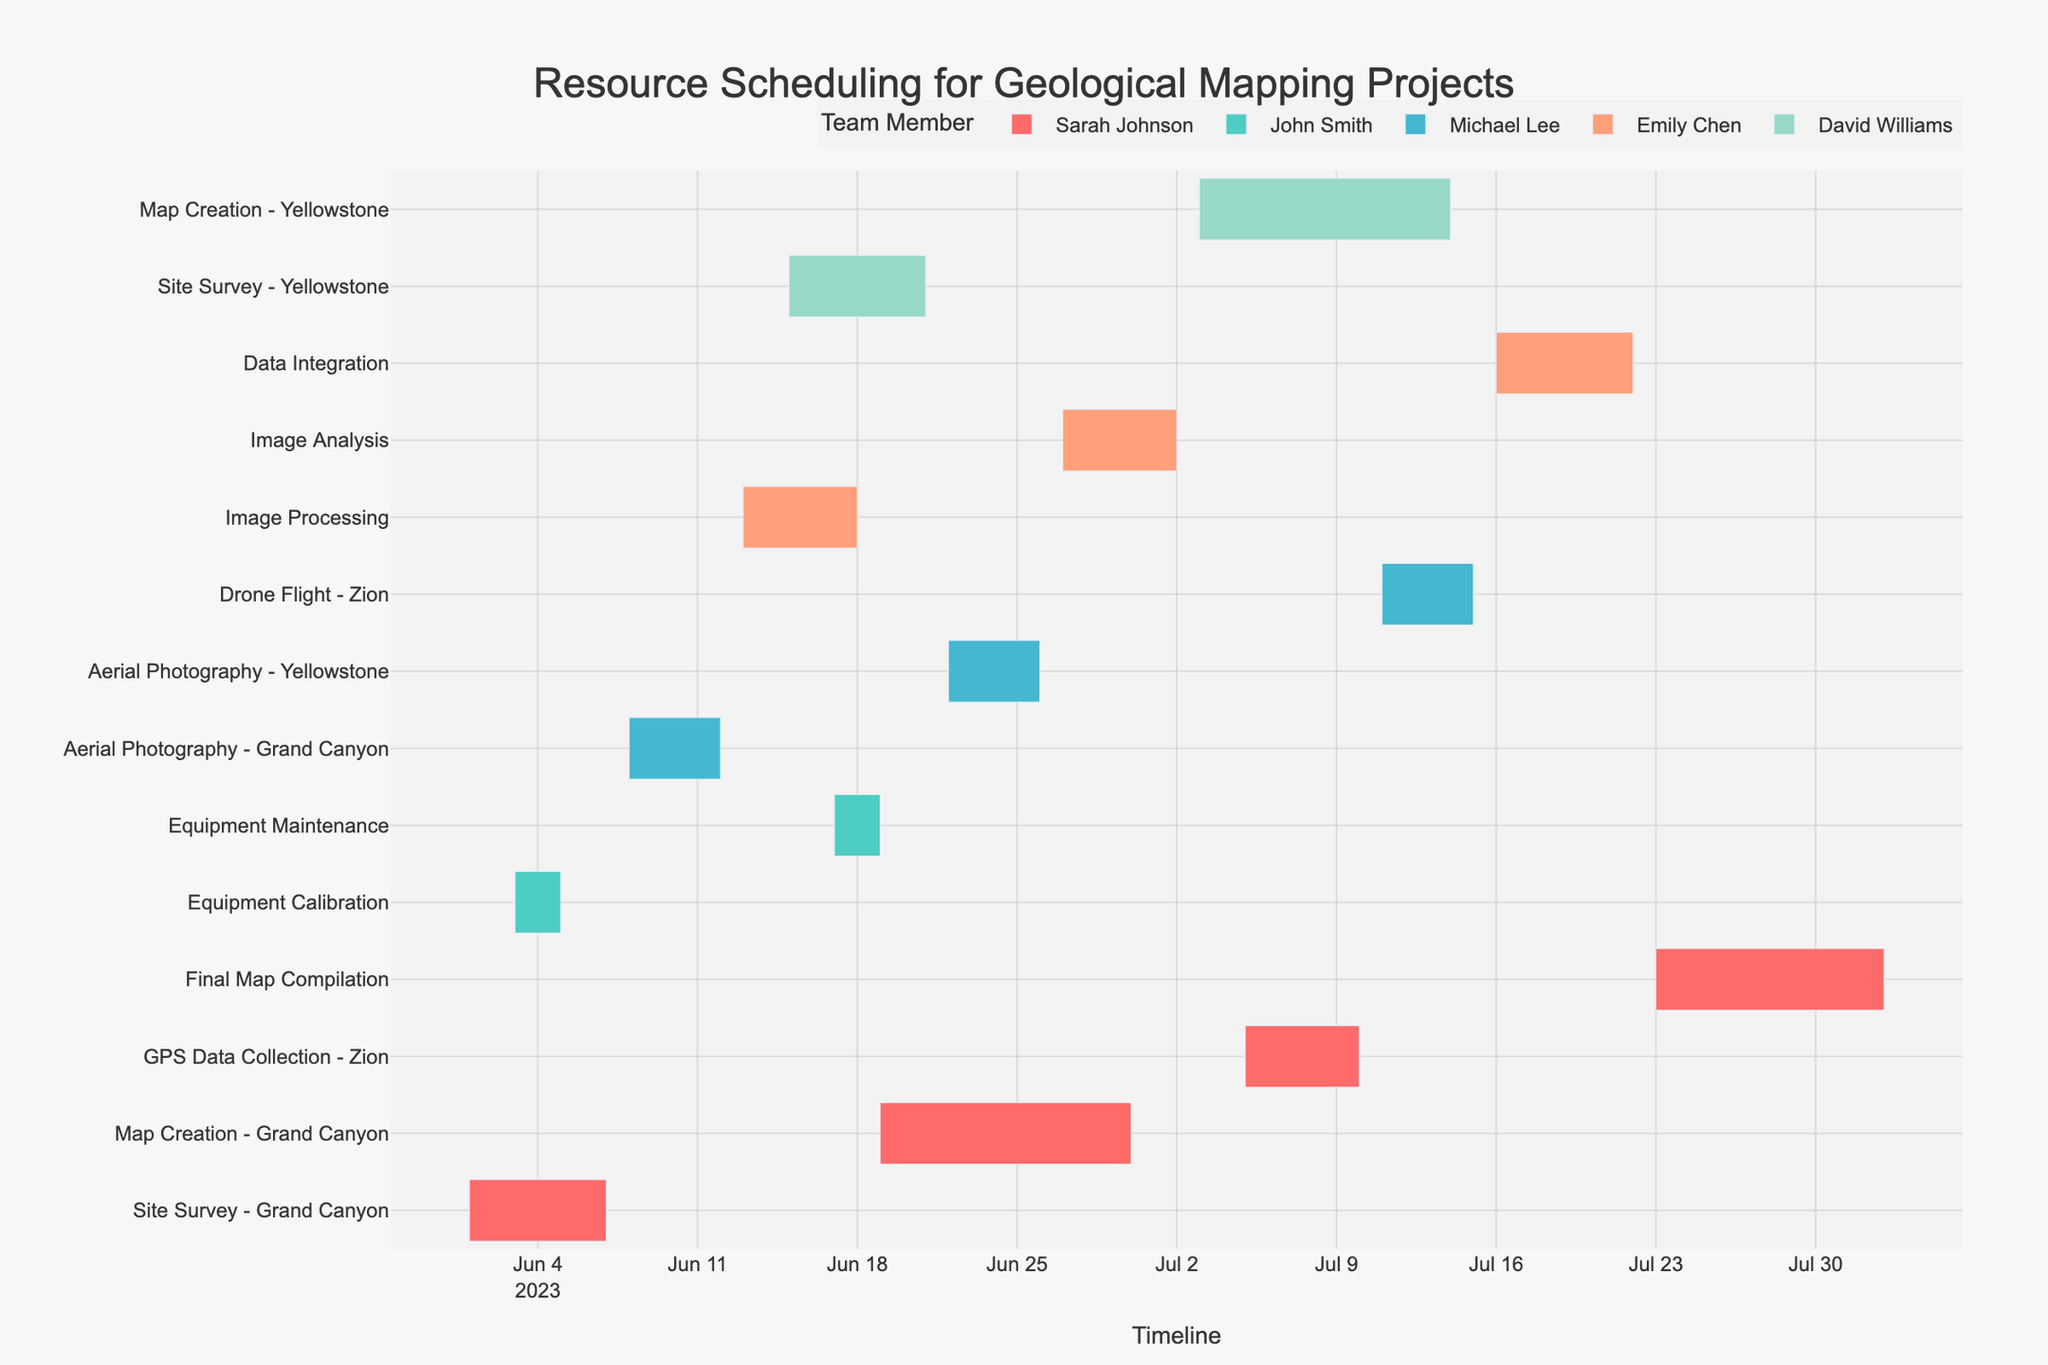Which task does Sarah Johnson start working on after June 7th? To find the task Sarah Johnson starts after June 7th, look for the next starting date on the Gantt chart. She starts working on "Map Creation - Grand Canyon" on June 19th, after the "Site Survey - Grand Canyon" ends on June 7th.
Answer: Map Creation - Grand Canyon What is the duration of the Site Survey - Grand Canyon task? The duration can be calculated by finding the difference between the end date (June 7) and the start date (June 1). The difference is 6 days.
Answer: 6 days Which resource is allocated for both Equipment Calibration and Equipment Maintenance? By examining the resources listed for both tasks on the Gantt chart, we see that John Smith is assigned to both "Equipment Calibration" and "Equipment Maintenance."
Answer: John Smith When does the Aerial Photography task at Yellowstone start and end? The Aerial Photography task at Yellowstone is listed with Michael Lee as the resource. Checking the dates on the Gantt chart, the task starts on June 22 and ends on June 26.
Answer: June 22 to June 26 What is the combined duration of all tasks assigned to Emily Chen? Emily Chen is assigned to "Image Processing" from June 13 to June 18 (6 days), "Image Analysis" from June 27 to July 2 (6 days), and "Data Integration" from July 16 to July 22 (7 days). Adding these durations: 6 + 6 + 7 = 19 days.
Answer: 19 days Which mapping site has the most tasks scheduled? By counting the tasks assigned to each mapping site on the Gantt chart: Grand Canyon has 3 tasks, Yellowstone has 4 tasks, and Zion has 2 tasks. Yellowstone has the most tasks scheduled.
Answer: Yellowstone Is there any overlap between equipment maintenance and any other task? Reviewing the timelines, "Equipment Maintenance" is scheduled from June 17 to June 19. "Site Survey - Yellowstone" from June 15 to June 21 and overlaps with "Equipment Maintenance" on June 17-19.
Answer: Yes, with Site Survey - Yellowstone How many days are there between the end of the Aerial Photography at Grand Canyon and the start of its Map Creation? The end date for "Aerial Photography - Grand Canyon" is June 12, and "Map Creation - Grand Canyon" starts on June 19. Calculating the days in between: June 19 - June 12 = 7 days.
Answer: 7 days What is the total span of the scheduling timeline from the earliest start date to the latest end date? The earliest start date is June 1 (Site Survey - Grand Canyon), and the latest end date is August 2 (Final Map Compilation). The total span is from June 1 to August 2.
Answer: June 1 to August 2 